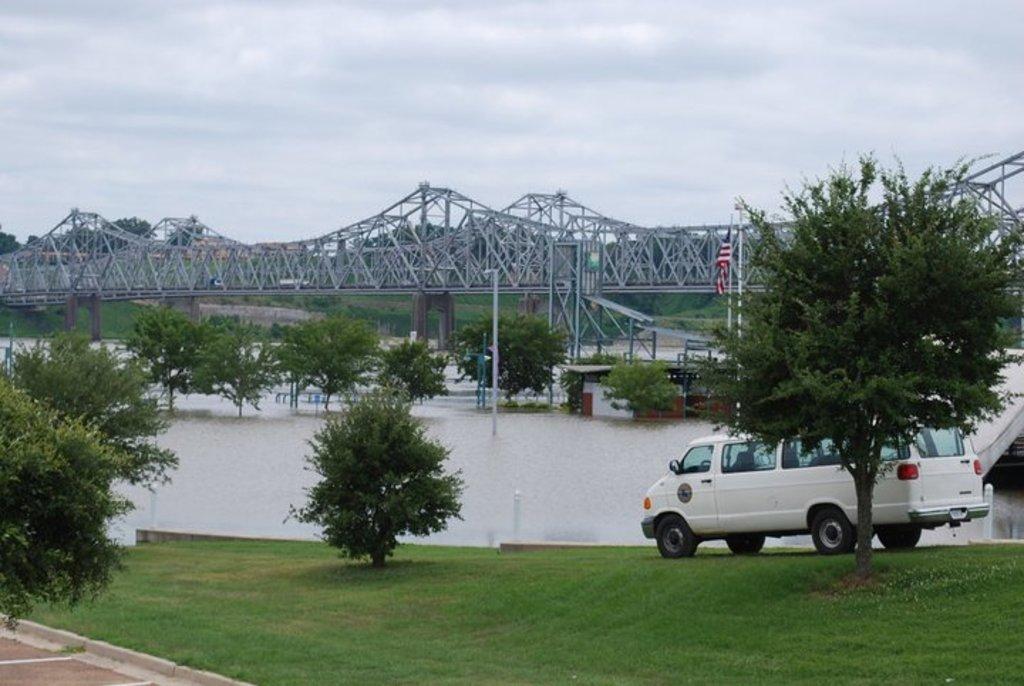How would you summarize this image in a sentence or two? In this image we can see plants, grass and vehicle on the ground. In the background we can see bridge, trees, water, flag pole, ropes and clouds in the sky. 